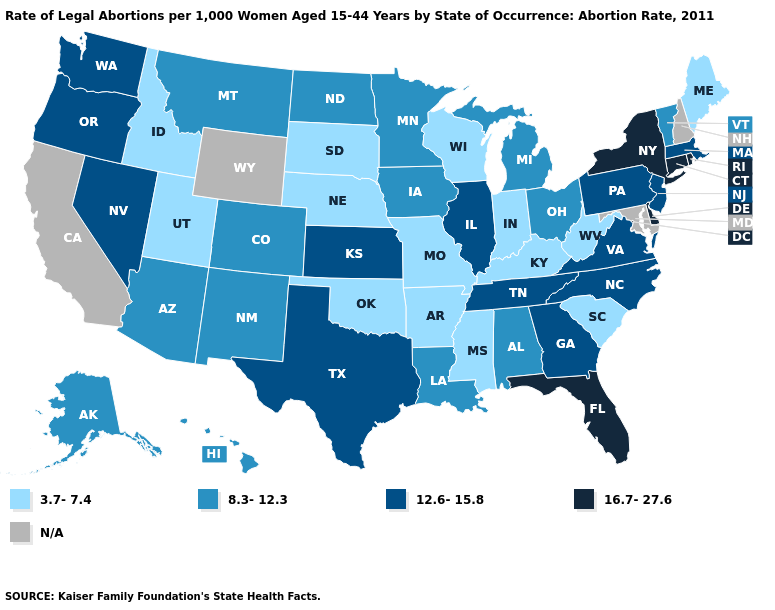Among the states that border New Jersey , which have the highest value?
Write a very short answer. Delaware, New York. What is the value of Idaho?
Give a very brief answer. 3.7-7.4. Among the states that border New Jersey , does Pennsylvania have the highest value?
Write a very short answer. No. What is the value of Kentucky?
Short answer required. 3.7-7.4. What is the lowest value in states that border Mississippi?
Quick response, please. 3.7-7.4. What is the highest value in the South ?
Quick response, please. 16.7-27.6. What is the value of Colorado?
Be succinct. 8.3-12.3. Among the states that border New Mexico , which have the lowest value?
Keep it brief. Oklahoma, Utah. Name the states that have a value in the range 3.7-7.4?
Answer briefly. Arkansas, Idaho, Indiana, Kentucky, Maine, Mississippi, Missouri, Nebraska, Oklahoma, South Carolina, South Dakota, Utah, West Virginia, Wisconsin. What is the value of California?
Keep it brief. N/A. Among the states that border Florida , does Georgia have the highest value?
Write a very short answer. Yes. What is the lowest value in states that border Idaho?
Write a very short answer. 3.7-7.4. Does the map have missing data?
Write a very short answer. Yes. 